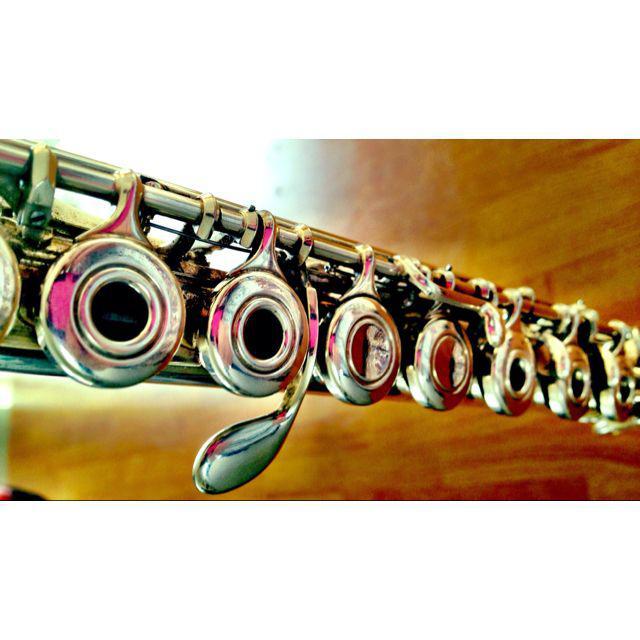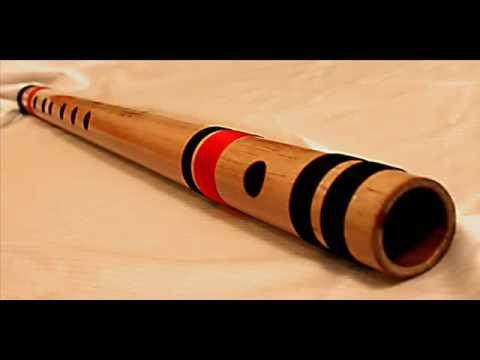The first image is the image on the left, the second image is the image on the right. Examine the images to the left and right. Is the description "There is a single instrument in each of the images, one of which is a flute." accurate? Answer yes or no. Yes. The first image is the image on the left, the second image is the image on the right. Analyze the images presented: Is the assertion "One image shows a horizontal row of round metal keys with open centers on a tube-shaped metal instrument, and the other image shows one wooden flute with holes but no keys and several stripes around it." valid? Answer yes or no. Yes. 